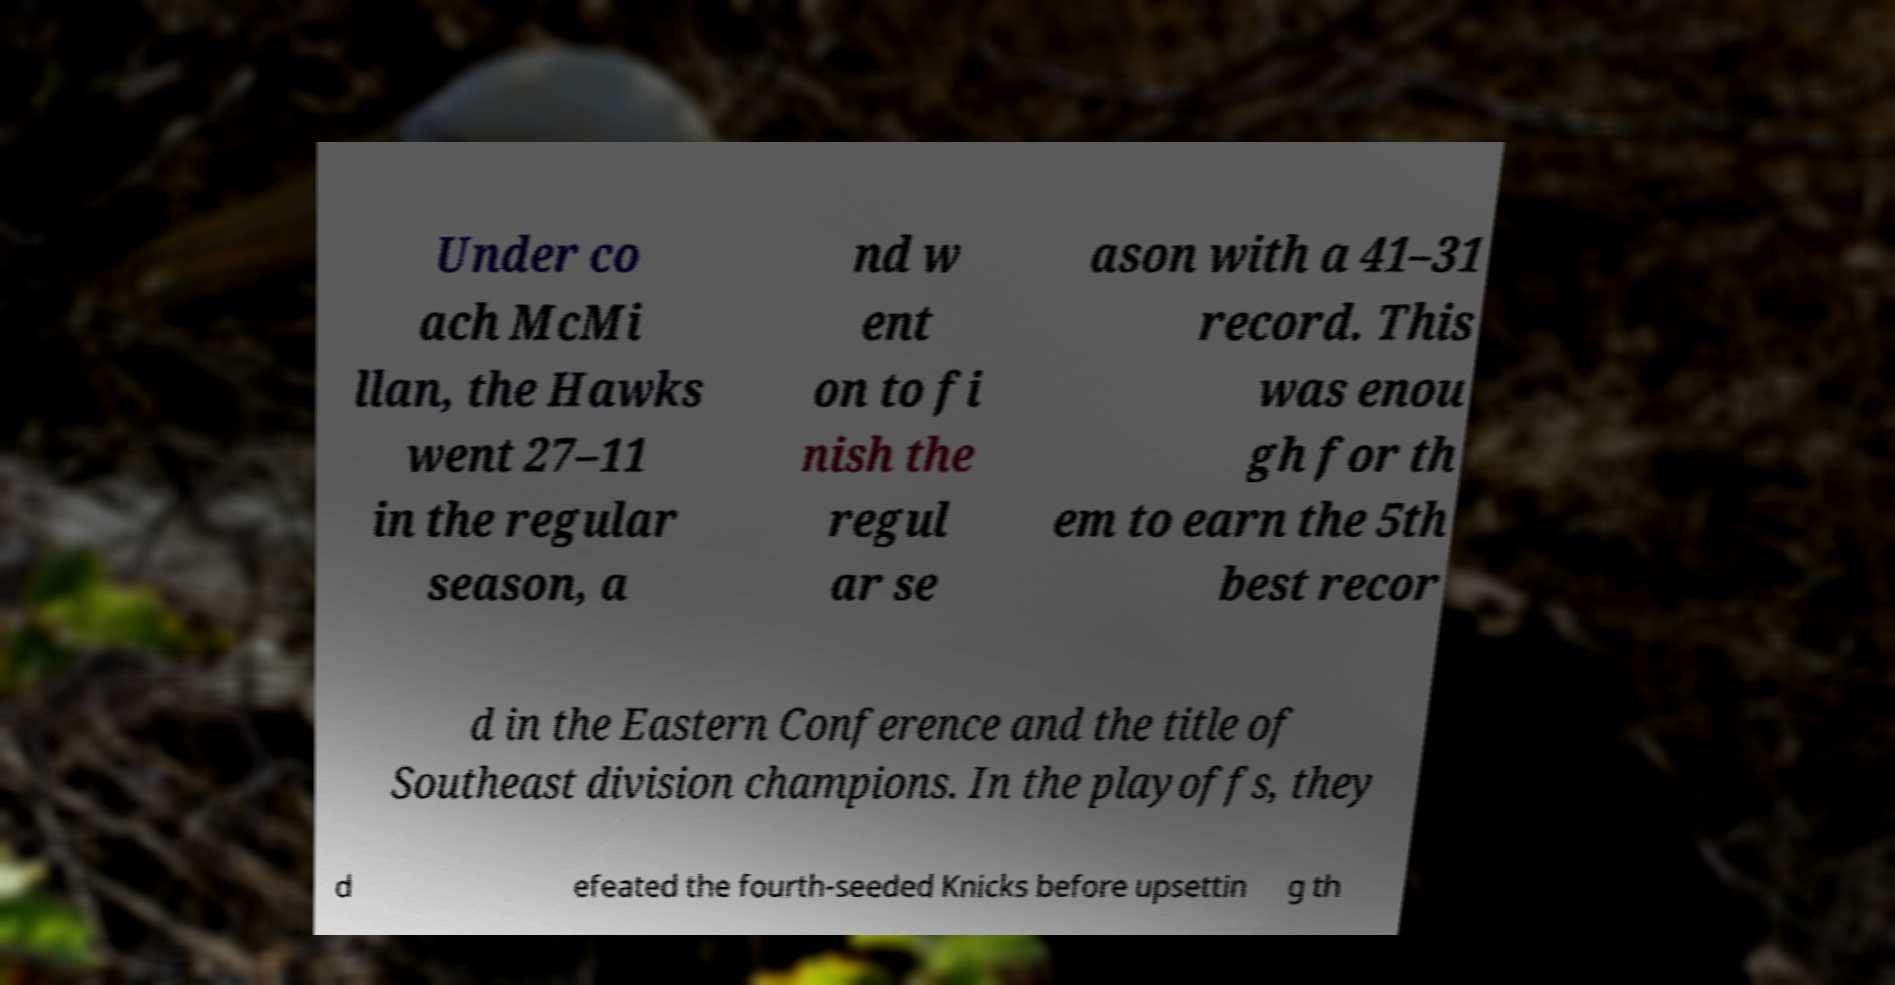Please read and relay the text visible in this image. What does it say? Under co ach McMi llan, the Hawks went 27–11 in the regular season, a nd w ent on to fi nish the regul ar se ason with a 41–31 record. This was enou gh for th em to earn the 5th best recor d in the Eastern Conference and the title of Southeast division champions. In the playoffs, they d efeated the fourth-seeded Knicks before upsettin g th 